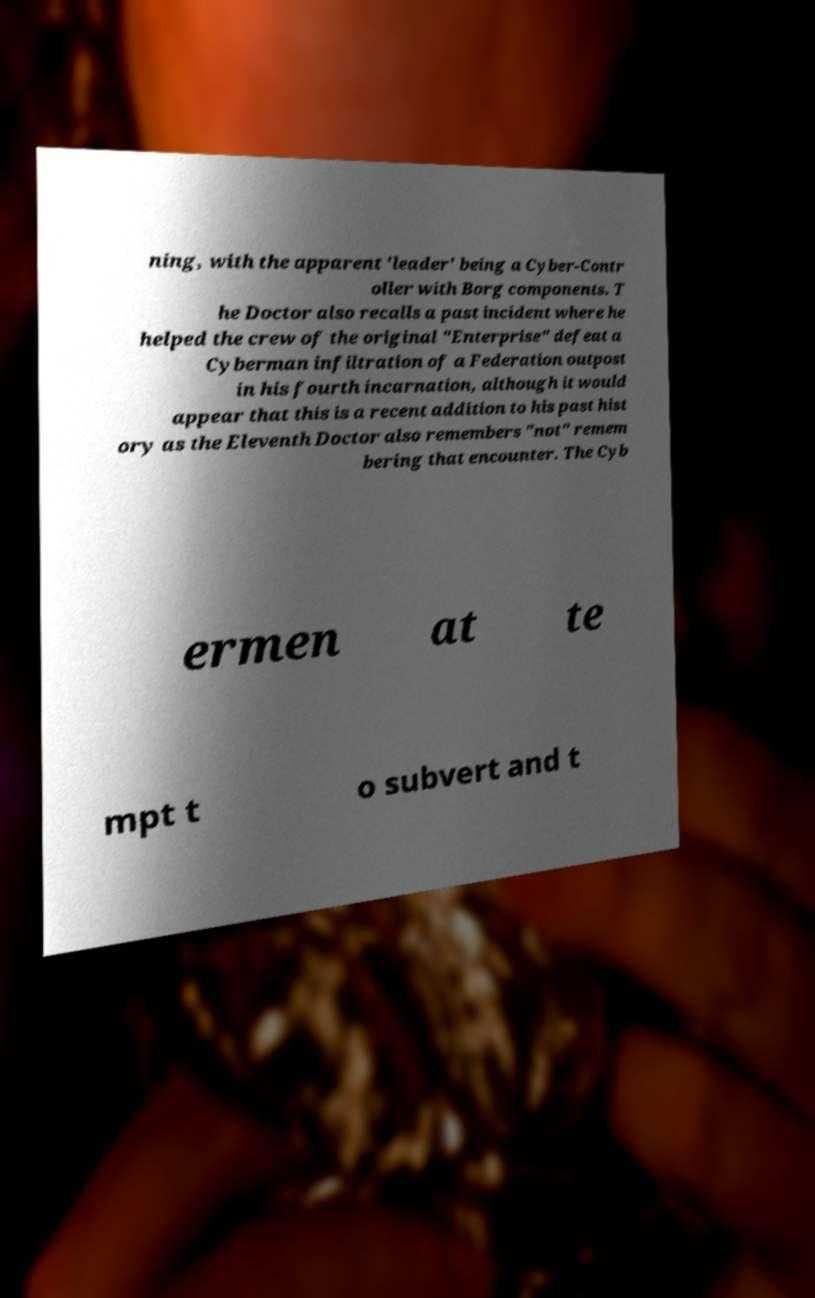Can you read and provide the text displayed in the image?This photo seems to have some interesting text. Can you extract and type it out for me? ning, with the apparent 'leader' being a Cyber-Contr oller with Borg components. T he Doctor also recalls a past incident where he helped the crew of the original "Enterprise" defeat a Cyberman infiltration of a Federation outpost in his fourth incarnation, although it would appear that this is a recent addition to his past hist ory as the Eleventh Doctor also remembers "not" remem bering that encounter. The Cyb ermen at te mpt t o subvert and t 